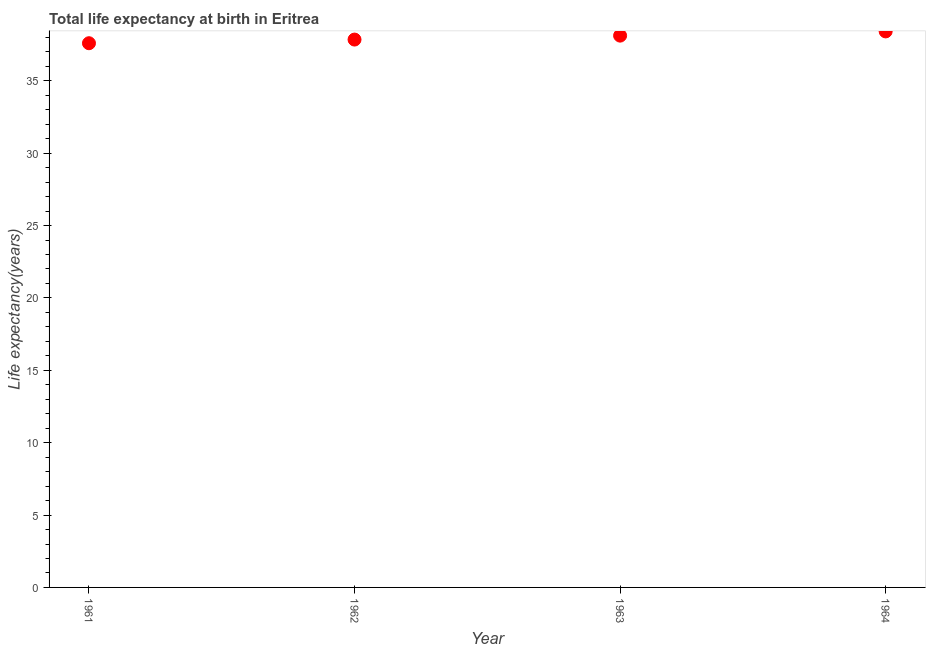What is the life expectancy at birth in 1962?
Make the answer very short. 37.85. Across all years, what is the maximum life expectancy at birth?
Give a very brief answer. 38.41. Across all years, what is the minimum life expectancy at birth?
Give a very brief answer. 37.6. In which year was the life expectancy at birth maximum?
Your answer should be very brief. 1964. What is the sum of the life expectancy at birth?
Provide a short and direct response. 151.99. What is the difference between the life expectancy at birth in 1961 and 1964?
Offer a terse response. -0.82. What is the average life expectancy at birth per year?
Your response must be concise. 38. What is the median life expectancy at birth?
Provide a succinct answer. 37.99. In how many years, is the life expectancy at birth greater than 28 years?
Your answer should be compact. 4. Do a majority of the years between 1962 and 1963 (inclusive) have life expectancy at birth greater than 3 years?
Offer a terse response. Yes. What is the ratio of the life expectancy at birth in 1962 to that in 1964?
Your answer should be compact. 0.99. Is the life expectancy at birth in 1963 less than that in 1964?
Provide a succinct answer. Yes. Is the difference between the life expectancy at birth in 1962 and 1963 greater than the difference between any two years?
Your answer should be compact. No. What is the difference between the highest and the second highest life expectancy at birth?
Provide a succinct answer. 0.29. Is the sum of the life expectancy at birth in 1963 and 1964 greater than the maximum life expectancy at birth across all years?
Give a very brief answer. Yes. What is the difference between the highest and the lowest life expectancy at birth?
Make the answer very short. 0.82. In how many years, is the life expectancy at birth greater than the average life expectancy at birth taken over all years?
Your response must be concise. 2. Does the life expectancy at birth monotonically increase over the years?
Give a very brief answer. Yes. How many dotlines are there?
Ensure brevity in your answer.  1. How many years are there in the graph?
Your answer should be very brief. 4. Does the graph contain any zero values?
Give a very brief answer. No. What is the title of the graph?
Your response must be concise. Total life expectancy at birth in Eritrea. What is the label or title of the X-axis?
Provide a short and direct response. Year. What is the label or title of the Y-axis?
Provide a succinct answer. Life expectancy(years). What is the Life expectancy(years) in 1961?
Provide a short and direct response. 37.6. What is the Life expectancy(years) in 1962?
Keep it short and to the point. 37.85. What is the Life expectancy(years) in 1963?
Keep it short and to the point. 38.12. What is the Life expectancy(years) in 1964?
Make the answer very short. 38.41. What is the difference between the Life expectancy(years) in 1961 and 1962?
Your response must be concise. -0.25. What is the difference between the Life expectancy(years) in 1961 and 1963?
Give a very brief answer. -0.52. What is the difference between the Life expectancy(years) in 1961 and 1964?
Make the answer very short. -0.82. What is the difference between the Life expectancy(years) in 1962 and 1963?
Your response must be concise. -0.27. What is the difference between the Life expectancy(years) in 1962 and 1964?
Your response must be concise. -0.56. What is the difference between the Life expectancy(years) in 1963 and 1964?
Your answer should be compact. -0.29. What is the ratio of the Life expectancy(years) in 1961 to that in 1962?
Offer a very short reply. 0.99. What is the ratio of the Life expectancy(years) in 1961 to that in 1963?
Offer a terse response. 0.99. What is the ratio of the Life expectancy(years) in 1961 to that in 1964?
Offer a terse response. 0.98. What is the ratio of the Life expectancy(years) in 1962 to that in 1963?
Give a very brief answer. 0.99. What is the ratio of the Life expectancy(years) in 1963 to that in 1964?
Offer a very short reply. 0.99. 